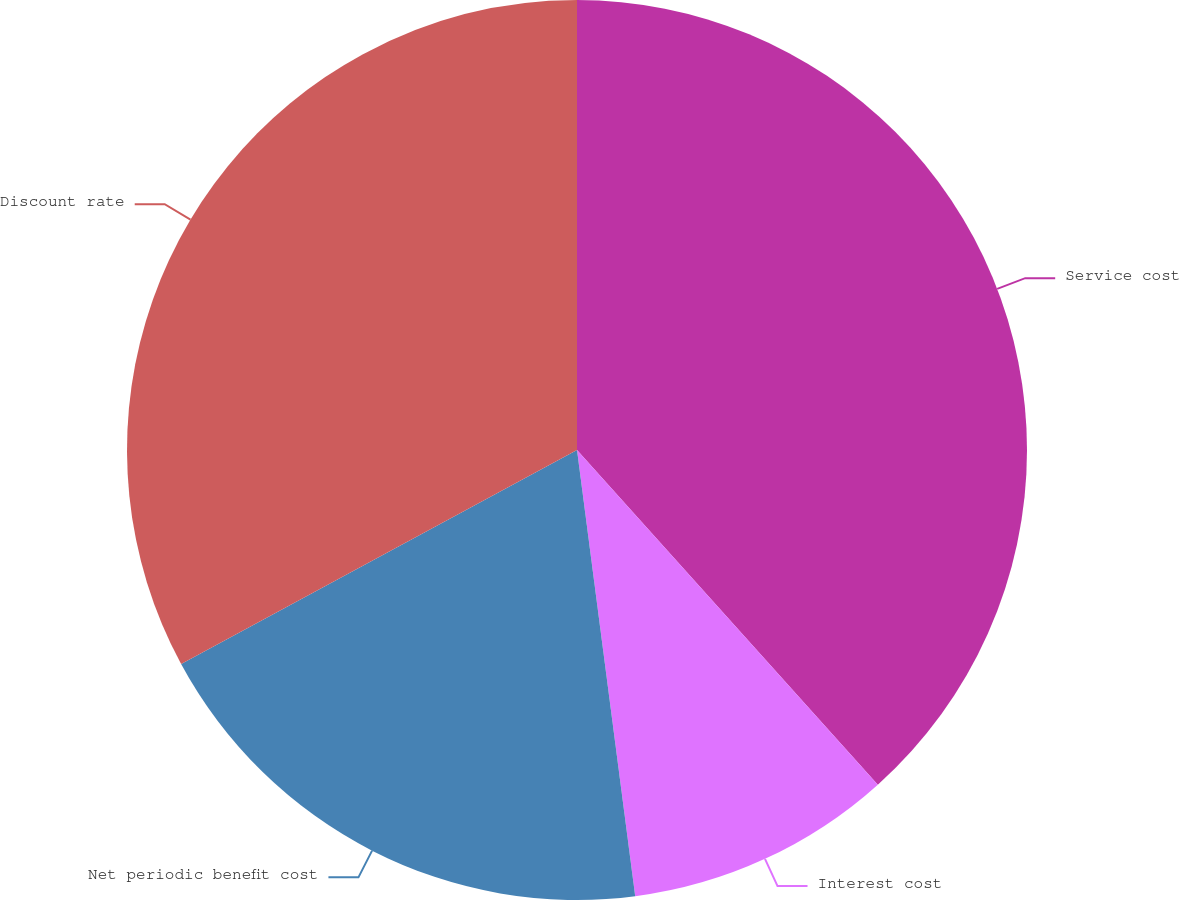Convert chart. <chart><loc_0><loc_0><loc_500><loc_500><pie_chart><fcel>Service cost<fcel>Interest cost<fcel>Net periodic benefit cost<fcel>Discount rate<nl><fcel>38.35%<fcel>9.59%<fcel>19.18%<fcel>32.89%<nl></chart> 